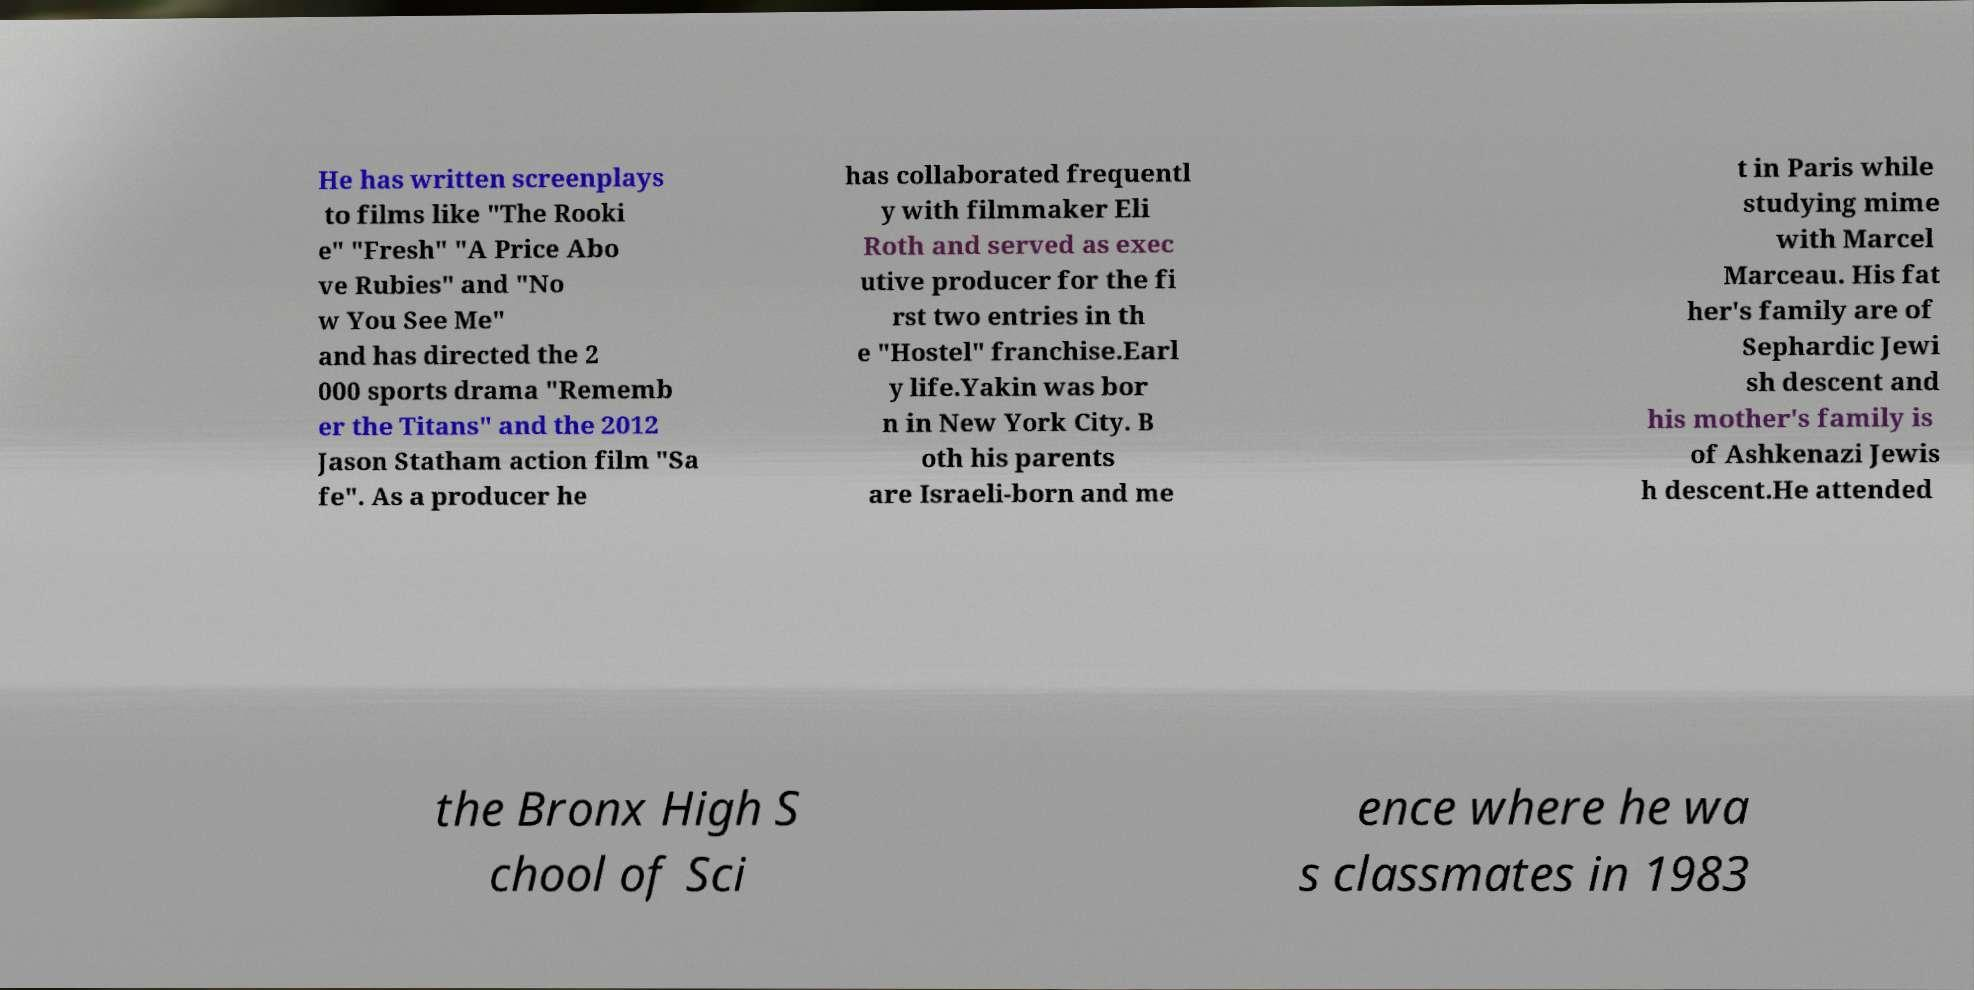There's text embedded in this image that I need extracted. Can you transcribe it verbatim? He has written screenplays to films like "The Rooki e" "Fresh" "A Price Abo ve Rubies" and "No w You See Me" and has directed the 2 000 sports drama "Rememb er the Titans" and the 2012 Jason Statham action film "Sa fe". As a producer he has collaborated frequentl y with filmmaker Eli Roth and served as exec utive producer for the fi rst two entries in th e "Hostel" franchise.Earl y life.Yakin was bor n in New York City. B oth his parents are Israeli-born and me t in Paris while studying mime with Marcel Marceau. His fat her's family are of Sephardic Jewi sh descent and his mother's family is of Ashkenazi Jewis h descent.He attended the Bronx High S chool of Sci ence where he wa s classmates in 1983 